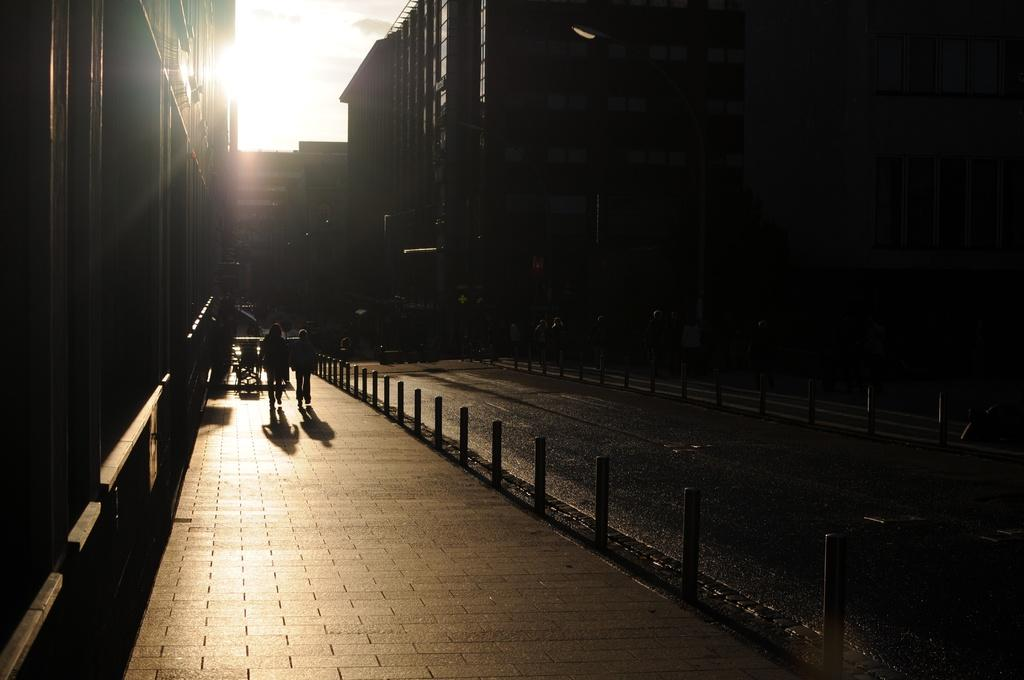What is the overall lighting condition in the image? The image is dark. Who or what can be seen in the image? There are people in the image. What structures are present in the image? There are poles and buildings in the image. What type of pathway is visible in the image? There is a road in the image. What can be seen in the background of the image? The sky is visible in the background of the image. What type of wood is used to make the pencil in the image? There is no pencil present in the image. What force is being applied to the buildings in the image? There is no force being applied to the buildings in the image; they are stationary. 